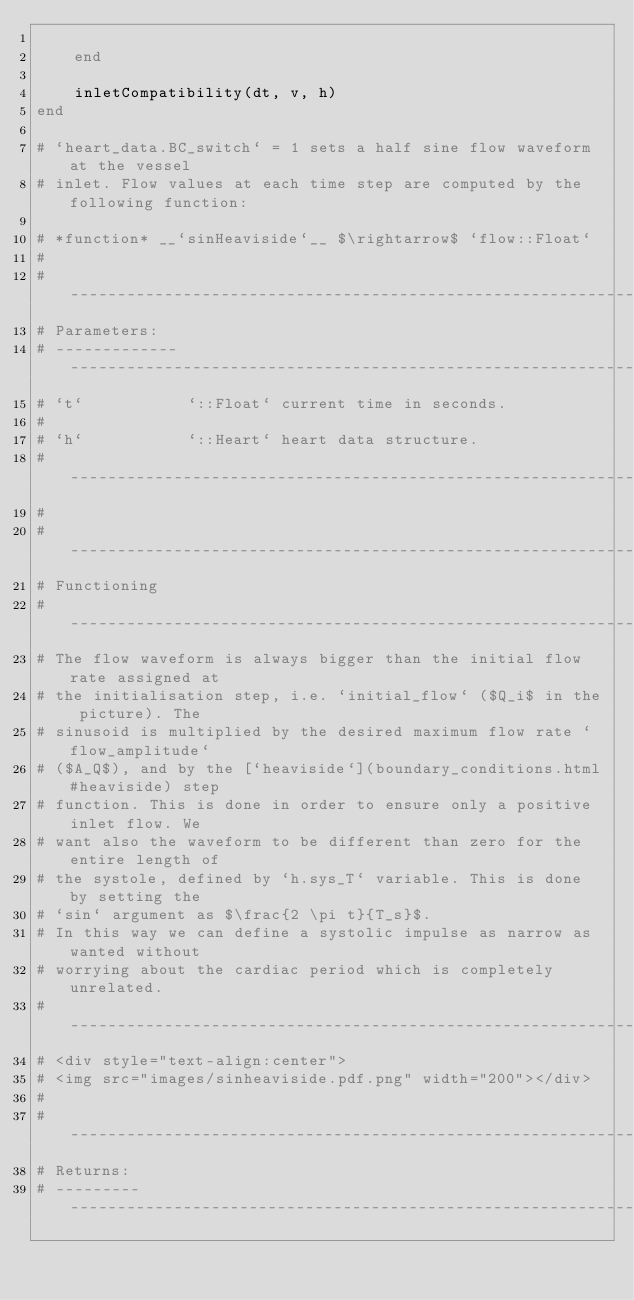<code> <loc_0><loc_0><loc_500><loc_500><_Julia_>
	end

	inletCompatibility(dt, v, h)
end

# `heart_data.BC_switch` = 1 sets a half sine flow waveform at the vessel
# inlet. Flow values at each time step are computed by the following function:

# *function* __`sinHeaviside`__ $\rightarrow$ `flow::Float`
#
# ----------------------------------------------------------------------------
# Parameters:
# ------------- --------------------------------------------------------------
# `t`           `::Float` current time in seconds.
#
# `h`           `::Heart` heart data structure.
# ----------------------------------------------------------------------------
#
# ----------------------------------------------------------------------------
# Functioning
# ----------------------------------------------------------------------------
# The flow waveform is always bigger than the initial flow rate assigned at
# the initialisation step, i.e. `initial_flow` ($Q_i$ in the picture). The
# sinusoid is multiplied by the desired maximum flow rate `flow_amplitude`
# ($A_Q$), and by the [`heaviside`](boundary_conditions.html#heaviside) step
# function. This is done in order to ensure only a positive inlet flow. We
# want also the waveform to be different than zero for the entire length of
# the systole, defined by `h.sys_T` variable. This is done by setting the
# `sin` argument as $\frac{2 \pi t}{T_s}$.
# In this way we can define a systolic impulse as narrow as wanted without
# worrying about the cardiac period which is completely unrelated.
# ----------------------------------------------------------------------------
# <div style="text-align:center">
# <img src="images/sinheaviside.pdf.png" width="200"></div>
#
# ----------------------------------------------------------------------------
# Returns:
# --------- ------------------------------------------------------------------</code> 